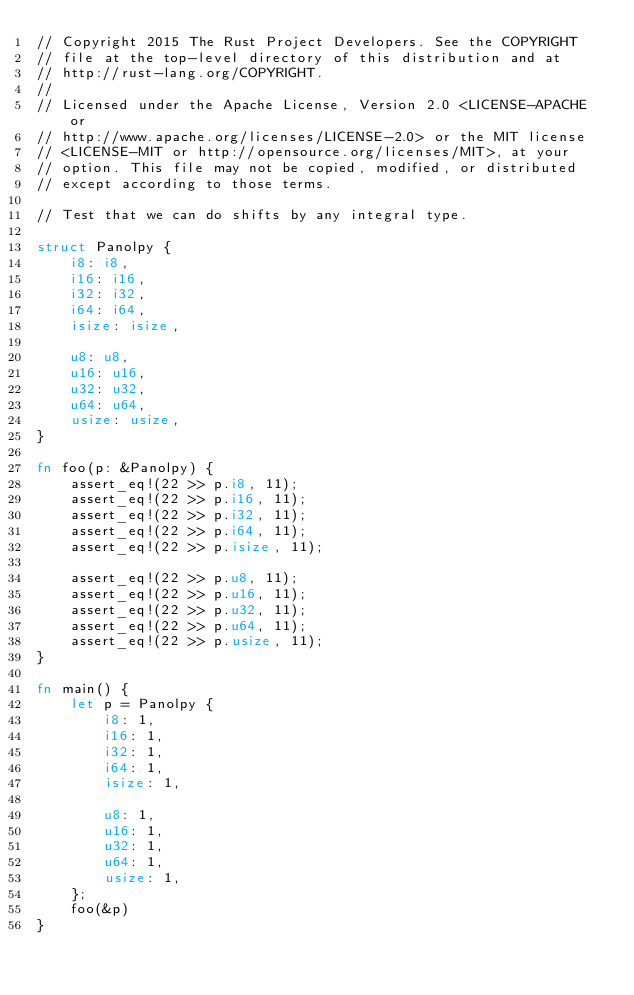Convert code to text. <code><loc_0><loc_0><loc_500><loc_500><_Rust_>// Copyright 2015 The Rust Project Developers. See the COPYRIGHT
// file at the top-level directory of this distribution and at
// http://rust-lang.org/COPYRIGHT.
//
// Licensed under the Apache License, Version 2.0 <LICENSE-APACHE or
// http://www.apache.org/licenses/LICENSE-2.0> or the MIT license
// <LICENSE-MIT or http://opensource.org/licenses/MIT>, at your
// option. This file may not be copied, modified, or distributed
// except according to those terms.

// Test that we can do shifts by any integral type.

struct Panolpy {
    i8: i8,
    i16: i16,
    i32: i32,
    i64: i64,
    isize: isize,

    u8: u8,
    u16: u16,
    u32: u32,
    u64: u64,
    usize: usize,
}

fn foo(p: &Panolpy) {
    assert_eq!(22 >> p.i8, 11);
    assert_eq!(22 >> p.i16, 11);
    assert_eq!(22 >> p.i32, 11);
    assert_eq!(22 >> p.i64, 11);
    assert_eq!(22 >> p.isize, 11);

    assert_eq!(22 >> p.u8, 11);
    assert_eq!(22 >> p.u16, 11);
    assert_eq!(22 >> p.u32, 11);
    assert_eq!(22 >> p.u64, 11);
    assert_eq!(22 >> p.usize, 11);
}

fn main() {
    let p = Panolpy {
        i8: 1,
        i16: 1,
        i32: 1,
        i64: 1,
        isize: 1,

        u8: 1,
        u16: 1,
        u32: 1,
        u64: 1,
        usize: 1,
    };
    foo(&p)
}
</code> 